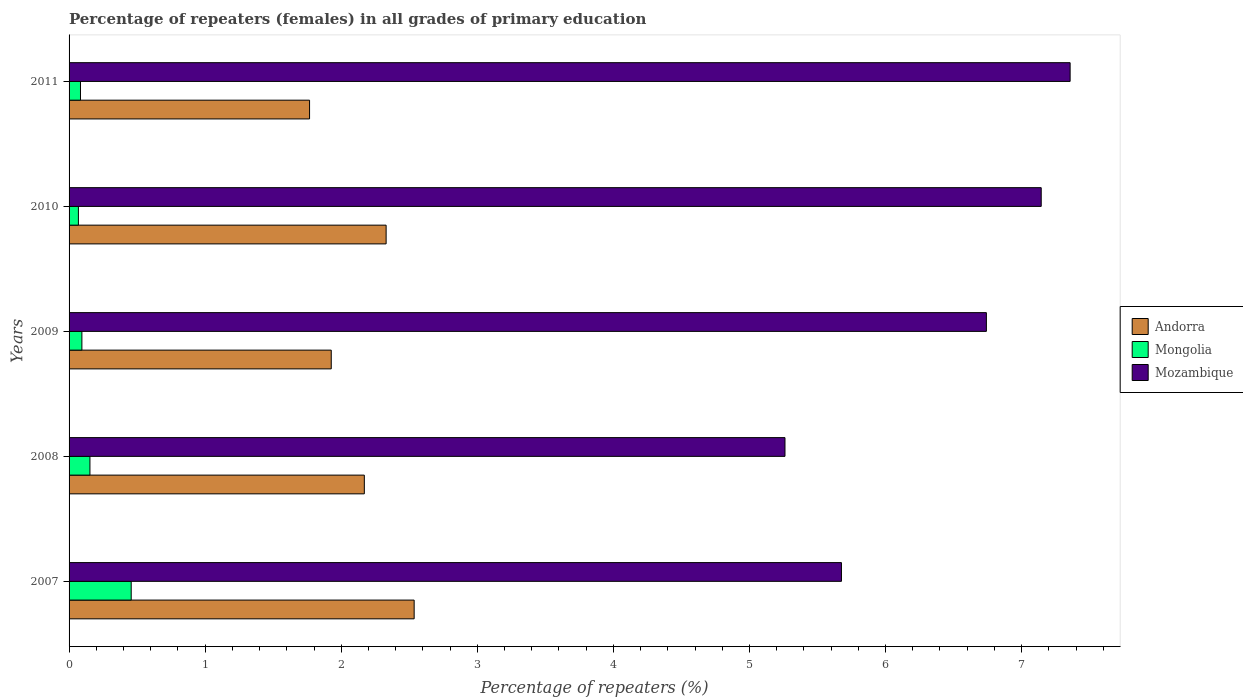How many different coloured bars are there?
Provide a short and direct response. 3. Are the number of bars per tick equal to the number of legend labels?
Your response must be concise. Yes. How many bars are there on the 2nd tick from the top?
Provide a succinct answer. 3. What is the label of the 4th group of bars from the top?
Your response must be concise. 2008. In how many cases, is the number of bars for a given year not equal to the number of legend labels?
Provide a short and direct response. 0. What is the percentage of repeaters (females) in Andorra in 2009?
Give a very brief answer. 1.93. Across all years, what is the maximum percentage of repeaters (females) in Mozambique?
Your response must be concise. 7.36. Across all years, what is the minimum percentage of repeaters (females) in Mongolia?
Offer a terse response. 0.07. What is the total percentage of repeaters (females) in Mozambique in the graph?
Your answer should be compact. 32.18. What is the difference between the percentage of repeaters (females) in Andorra in 2010 and that in 2011?
Provide a short and direct response. 0.56. What is the difference between the percentage of repeaters (females) in Mongolia in 2009 and the percentage of repeaters (females) in Andorra in 2007?
Give a very brief answer. -2.44. What is the average percentage of repeaters (females) in Mozambique per year?
Make the answer very short. 6.44. In the year 2008, what is the difference between the percentage of repeaters (females) in Andorra and percentage of repeaters (females) in Mozambique?
Make the answer very short. -3.09. In how many years, is the percentage of repeaters (females) in Mongolia greater than 4.8 %?
Keep it short and to the point. 0. What is the ratio of the percentage of repeaters (females) in Mongolia in 2007 to that in 2008?
Keep it short and to the point. 2.98. What is the difference between the highest and the second highest percentage of repeaters (females) in Mongolia?
Offer a very short reply. 0.3. What is the difference between the highest and the lowest percentage of repeaters (females) in Andorra?
Offer a very short reply. 0.77. In how many years, is the percentage of repeaters (females) in Mozambique greater than the average percentage of repeaters (females) in Mozambique taken over all years?
Provide a succinct answer. 3. What does the 1st bar from the top in 2009 represents?
Your response must be concise. Mozambique. What does the 1st bar from the bottom in 2010 represents?
Make the answer very short. Andorra. Is it the case that in every year, the sum of the percentage of repeaters (females) in Mozambique and percentage of repeaters (females) in Mongolia is greater than the percentage of repeaters (females) in Andorra?
Provide a succinct answer. Yes. Are all the bars in the graph horizontal?
Your response must be concise. Yes. Are the values on the major ticks of X-axis written in scientific E-notation?
Ensure brevity in your answer.  No. Does the graph contain any zero values?
Offer a terse response. No. How many legend labels are there?
Offer a very short reply. 3. How are the legend labels stacked?
Your response must be concise. Vertical. What is the title of the graph?
Provide a succinct answer. Percentage of repeaters (females) in all grades of primary education. Does "East Asia (all income levels)" appear as one of the legend labels in the graph?
Offer a very short reply. No. What is the label or title of the X-axis?
Give a very brief answer. Percentage of repeaters (%). What is the label or title of the Y-axis?
Give a very brief answer. Years. What is the Percentage of repeaters (%) of Andorra in 2007?
Your answer should be very brief. 2.54. What is the Percentage of repeaters (%) of Mongolia in 2007?
Ensure brevity in your answer.  0.46. What is the Percentage of repeaters (%) in Mozambique in 2007?
Your answer should be very brief. 5.68. What is the Percentage of repeaters (%) of Andorra in 2008?
Make the answer very short. 2.17. What is the Percentage of repeaters (%) in Mongolia in 2008?
Make the answer very short. 0.15. What is the Percentage of repeaters (%) of Mozambique in 2008?
Keep it short and to the point. 5.26. What is the Percentage of repeaters (%) of Andorra in 2009?
Offer a very short reply. 1.93. What is the Percentage of repeaters (%) of Mongolia in 2009?
Offer a very short reply. 0.09. What is the Percentage of repeaters (%) in Mozambique in 2009?
Offer a very short reply. 6.74. What is the Percentage of repeaters (%) in Andorra in 2010?
Your answer should be very brief. 2.33. What is the Percentage of repeaters (%) of Mongolia in 2010?
Provide a short and direct response. 0.07. What is the Percentage of repeaters (%) of Mozambique in 2010?
Keep it short and to the point. 7.14. What is the Percentage of repeaters (%) of Andorra in 2011?
Provide a short and direct response. 1.77. What is the Percentage of repeaters (%) in Mongolia in 2011?
Make the answer very short. 0.08. What is the Percentage of repeaters (%) of Mozambique in 2011?
Offer a terse response. 7.36. Across all years, what is the maximum Percentage of repeaters (%) of Andorra?
Offer a very short reply. 2.54. Across all years, what is the maximum Percentage of repeaters (%) of Mongolia?
Make the answer very short. 0.46. Across all years, what is the maximum Percentage of repeaters (%) in Mozambique?
Offer a very short reply. 7.36. Across all years, what is the minimum Percentage of repeaters (%) in Andorra?
Make the answer very short. 1.77. Across all years, what is the minimum Percentage of repeaters (%) in Mongolia?
Your answer should be very brief. 0.07. Across all years, what is the minimum Percentage of repeaters (%) in Mozambique?
Your answer should be compact. 5.26. What is the total Percentage of repeaters (%) in Andorra in the graph?
Offer a very short reply. 10.73. What is the total Percentage of repeaters (%) in Mongolia in the graph?
Ensure brevity in your answer.  0.86. What is the total Percentage of repeaters (%) of Mozambique in the graph?
Offer a very short reply. 32.18. What is the difference between the Percentage of repeaters (%) of Andorra in 2007 and that in 2008?
Offer a terse response. 0.37. What is the difference between the Percentage of repeaters (%) of Mongolia in 2007 and that in 2008?
Your answer should be compact. 0.3. What is the difference between the Percentage of repeaters (%) in Mozambique in 2007 and that in 2008?
Provide a short and direct response. 0.41. What is the difference between the Percentage of repeaters (%) of Andorra in 2007 and that in 2009?
Your answer should be compact. 0.61. What is the difference between the Percentage of repeaters (%) of Mongolia in 2007 and that in 2009?
Give a very brief answer. 0.36. What is the difference between the Percentage of repeaters (%) of Mozambique in 2007 and that in 2009?
Give a very brief answer. -1.07. What is the difference between the Percentage of repeaters (%) of Andorra in 2007 and that in 2010?
Offer a very short reply. 0.21. What is the difference between the Percentage of repeaters (%) in Mongolia in 2007 and that in 2010?
Your answer should be very brief. 0.39. What is the difference between the Percentage of repeaters (%) in Mozambique in 2007 and that in 2010?
Offer a very short reply. -1.47. What is the difference between the Percentage of repeaters (%) of Andorra in 2007 and that in 2011?
Ensure brevity in your answer.  0.77. What is the difference between the Percentage of repeaters (%) of Mongolia in 2007 and that in 2011?
Ensure brevity in your answer.  0.37. What is the difference between the Percentage of repeaters (%) of Mozambique in 2007 and that in 2011?
Provide a short and direct response. -1.68. What is the difference between the Percentage of repeaters (%) in Andorra in 2008 and that in 2009?
Ensure brevity in your answer.  0.24. What is the difference between the Percentage of repeaters (%) in Mongolia in 2008 and that in 2009?
Offer a very short reply. 0.06. What is the difference between the Percentage of repeaters (%) in Mozambique in 2008 and that in 2009?
Give a very brief answer. -1.48. What is the difference between the Percentage of repeaters (%) in Andorra in 2008 and that in 2010?
Offer a very short reply. -0.16. What is the difference between the Percentage of repeaters (%) in Mongolia in 2008 and that in 2010?
Offer a terse response. 0.08. What is the difference between the Percentage of repeaters (%) in Mozambique in 2008 and that in 2010?
Your answer should be compact. -1.88. What is the difference between the Percentage of repeaters (%) in Andorra in 2008 and that in 2011?
Provide a short and direct response. 0.4. What is the difference between the Percentage of repeaters (%) of Mongolia in 2008 and that in 2011?
Give a very brief answer. 0.07. What is the difference between the Percentage of repeaters (%) of Mozambique in 2008 and that in 2011?
Keep it short and to the point. -2.1. What is the difference between the Percentage of repeaters (%) of Andorra in 2009 and that in 2010?
Your response must be concise. -0.4. What is the difference between the Percentage of repeaters (%) of Mongolia in 2009 and that in 2010?
Offer a very short reply. 0.03. What is the difference between the Percentage of repeaters (%) of Mozambique in 2009 and that in 2010?
Offer a terse response. -0.4. What is the difference between the Percentage of repeaters (%) in Andorra in 2009 and that in 2011?
Make the answer very short. 0.16. What is the difference between the Percentage of repeaters (%) in Mongolia in 2009 and that in 2011?
Your answer should be very brief. 0.01. What is the difference between the Percentage of repeaters (%) of Mozambique in 2009 and that in 2011?
Provide a short and direct response. -0.62. What is the difference between the Percentage of repeaters (%) of Andorra in 2010 and that in 2011?
Your response must be concise. 0.56. What is the difference between the Percentage of repeaters (%) in Mongolia in 2010 and that in 2011?
Your answer should be very brief. -0.02. What is the difference between the Percentage of repeaters (%) in Mozambique in 2010 and that in 2011?
Offer a very short reply. -0.21. What is the difference between the Percentage of repeaters (%) in Andorra in 2007 and the Percentage of repeaters (%) in Mongolia in 2008?
Give a very brief answer. 2.38. What is the difference between the Percentage of repeaters (%) of Andorra in 2007 and the Percentage of repeaters (%) of Mozambique in 2008?
Your answer should be compact. -2.73. What is the difference between the Percentage of repeaters (%) in Mongolia in 2007 and the Percentage of repeaters (%) in Mozambique in 2008?
Your response must be concise. -4.8. What is the difference between the Percentage of repeaters (%) of Andorra in 2007 and the Percentage of repeaters (%) of Mongolia in 2009?
Your response must be concise. 2.44. What is the difference between the Percentage of repeaters (%) of Andorra in 2007 and the Percentage of repeaters (%) of Mozambique in 2009?
Ensure brevity in your answer.  -4.21. What is the difference between the Percentage of repeaters (%) in Mongolia in 2007 and the Percentage of repeaters (%) in Mozambique in 2009?
Offer a very short reply. -6.28. What is the difference between the Percentage of repeaters (%) in Andorra in 2007 and the Percentage of repeaters (%) in Mongolia in 2010?
Make the answer very short. 2.47. What is the difference between the Percentage of repeaters (%) in Andorra in 2007 and the Percentage of repeaters (%) in Mozambique in 2010?
Provide a short and direct response. -4.61. What is the difference between the Percentage of repeaters (%) in Mongolia in 2007 and the Percentage of repeaters (%) in Mozambique in 2010?
Give a very brief answer. -6.69. What is the difference between the Percentage of repeaters (%) of Andorra in 2007 and the Percentage of repeaters (%) of Mongolia in 2011?
Make the answer very short. 2.45. What is the difference between the Percentage of repeaters (%) in Andorra in 2007 and the Percentage of repeaters (%) in Mozambique in 2011?
Provide a succinct answer. -4.82. What is the difference between the Percentage of repeaters (%) in Mongolia in 2007 and the Percentage of repeaters (%) in Mozambique in 2011?
Your response must be concise. -6.9. What is the difference between the Percentage of repeaters (%) of Andorra in 2008 and the Percentage of repeaters (%) of Mongolia in 2009?
Provide a short and direct response. 2.08. What is the difference between the Percentage of repeaters (%) in Andorra in 2008 and the Percentage of repeaters (%) in Mozambique in 2009?
Ensure brevity in your answer.  -4.57. What is the difference between the Percentage of repeaters (%) in Mongolia in 2008 and the Percentage of repeaters (%) in Mozambique in 2009?
Provide a short and direct response. -6.59. What is the difference between the Percentage of repeaters (%) of Andorra in 2008 and the Percentage of repeaters (%) of Mongolia in 2010?
Offer a very short reply. 2.1. What is the difference between the Percentage of repeaters (%) of Andorra in 2008 and the Percentage of repeaters (%) of Mozambique in 2010?
Your answer should be compact. -4.97. What is the difference between the Percentage of repeaters (%) in Mongolia in 2008 and the Percentage of repeaters (%) in Mozambique in 2010?
Make the answer very short. -6.99. What is the difference between the Percentage of repeaters (%) in Andorra in 2008 and the Percentage of repeaters (%) in Mongolia in 2011?
Give a very brief answer. 2.09. What is the difference between the Percentage of repeaters (%) in Andorra in 2008 and the Percentage of repeaters (%) in Mozambique in 2011?
Provide a succinct answer. -5.19. What is the difference between the Percentage of repeaters (%) of Mongolia in 2008 and the Percentage of repeaters (%) of Mozambique in 2011?
Make the answer very short. -7.2. What is the difference between the Percentage of repeaters (%) of Andorra in 2009 and the Percentage of repeaters (%) of Mongolia in 2010?
Provide a succinct answer. 1.86. What is the difference between the Percentage of repeaters (%) in Andorra in 2009 and the Percentage of repeaters (%) in Mozambique in 2010?
Keep it short and to the point. -5.22. What is the difference between the Percentage of repeaters (%) in Mongolia in 2009 and the Percentage of repeaters (%) in Mozambique in 2010?
Offer a very short reply. -7.05. What is the difference between the Percentage of repeaters (%) of Andorra in 2009 and the Percentage of repeaters (%) of Mongolia in 2011?
Keep it short and to the point. 1.84. What is the difference between the Percentage of repeaters (%) in Andorra in 2009 and the Percentage of repeaters (%) in Mozambique in 2011?
Your response must be concise. -5.43. What is the difference between the Percentage of repeaters (%) of Mongolia in 2009 and the Percentage of repeaters (%) of Mozambique in 2011?
Give a very brief answer. -7.26. What is the difference between the Percentage of repeaters (%) in Andorra in 2010 and the Percentage of repeaters (%) in Mongolia in 2011?
Your answer should be very brief. 2.25. What is the difference between the Percentage of repeaters (%) in Andorra in 2010 and the Percentage of repeaters (%) in Mozambique in 2011?
Provide a succinct answer. -5.03. What is the difference between the Percentage of repeaters (%) of Mongolia in 2010 and the Percentage of repeaters (%) of Mozambique in 2011?
Your answer should be very brief. -7.29. What is the average Percentage of repeaters (%) in Andorra per year?
Ensure brevity in your answer.  2.15. What is the average Percentage of repeaters (%) of Mongolia per year?
Your answer should be compact. 0.17. What is the average Percentage of repeaters (%) in Mozambique per year?
Your answer should be compact. 6.44. In the year 2007, what is the difference between the Percentage of repeaters (%) in Andorra and Percentage of repeaters (%) in Mongolia?
Ensure brevity in your answer.  2.08. In the year 2007, what is the difference between the Percentage of repeaters (%) in Andorra and Percentage of repeaters (%) in Mozambique?
Your answer should be compact. -3.14. In the year 2007, what is the difference between the Percentage of repeaters (%) in Mongolia and Percentage of repeaters (%) in Mozambique?
Offer a very short reply. -5.22. In the year 2008, what is the difference between the Percentage of repeaters (%) in Andorra and Percentage of repeaters (%) in Mongolia?
Your answer should be compact. 2.02. In the year 2008, what is the difference between the Percentage of repeaters (%) of Andorra and Percentage of repeaters (%) of Mozambique?
Your response must be concise. -3.09. In the year 2008, what is the difference between the Percentage of repeaters (%) of Mongolia and Percentage of repeaters (%) of Mozambique?
Provide a short and direct response. -5.11. In the year 2009, what is the difference between the Percentage of repeaters (%) in Andorra and Percentage of repeaters (%) in Mongolia?
Give a very brief answer. 1.83. In the year 2009, what is the difference between the Percentage of repeaters (%) of Andorra and Percentage of repeaters (%) of Mozambique?
Offer a very short reply. -4.81. In the year 2009, what is the difference between the Percentage of repeaters (%) in Mongolia and Percentage of repeaters (%) in Mozambique?
Keep it short and to the point. -6.65. In the year 2010, what is the difference between the Percentage of repeaters (%) of Andorra and Percentage of repeaters (%) of Mongolia?
Offer a very short reply. 2.26. In the year 2010, what is the difference between the Percentage of repeaters (%) in Andorra and Percentage of repeaters (%) in Mozambique?
Provide a succinct answer. -4.81. In the year 2010, what is the difference between the Percentage of repeaters (%) in Mongolia and Percentage of repeaters (%) in Mozambique?
Your response must be concise. -7.08. In the year 2011, what is the difference between the Percentage of repeaters (%) of Andorra and Percentage of repeaters (%) of Mongolia?
Make the answer very short. 1.68. In the year 2011, what is the difference between the Percentage of repeaters (%) in Andorra and Percentage of repeaters (%) in Mozambique?
Your answer should be very brief. -5.59. In the year 2011, what is the difference between the Percentage of repeaters (%) of Mongolia and Percentage of repeaters (%) of Mozambique?
Your response must be concise. -7.27. What is the ratio of the Percentage of repeaters (%) of Andorra in 2007 to that in 2008?
Provide a short and direct response. 1.17. What is the ratio of the Percentage of repeaters (%) in Mongolia in 2007 to that in 2008?
Give a very brief answer. 2.98. What is the ratio of the Percentage of repeaters (%) of Mozambique in 2007 to that in 2008?
Keep it short and to the point. 1.08. What is the ratio of the Percentage of repeaters (%) in Andorra in 2007 to that in 2009?
Ensure brevity in your answer.  1.32. What is the ratio of the Percentage of repeaters (%) of Mongolia in 2007 to that in 2009?
Offer a terse response. 4.85. What is the ratio of the Percentage of repeaters (%) in Mozambique in 2007 to that in 2009?
Make the answer very short. 0.84. What is the ratio of the Percentage of repeaters (%) of Andorra in 2007 to that in 2010?
Offer a very short reply. 1.09. What is the ratio of the Percentage of repeaters (%) in Mongolia in 2007 to that in 2010?
Your response must be concise. 6.66. What is the ratio of the Percentage of repeaters (%) of Mozambique in 2007 to that in 2010?
Ensure brevity in your answer.  0.79. What is the ratio of the Percentage of repeaters (%) of Andorra in 2007 to that in 2011?
Offer a terse response. 1.43. What is the ratio of the Percentage of repeaters (%) of Mongolia in 2007 to that in 2011?
Offer a terse response. 5.44. What is the ratio of the Percentage of repeaters (%) in Mozambique in 2007 to that in 2011?
Offer a very short reply. 0.77. What is the ratio of the Percentage of repeaters (%) of Andorra in 2008 to that in 2009?
Give a very brief answer. 1.13. What is the ratio of the Percentage of repeaters (%) in Mongolia in 2008 to that in 2009?
Your answer should be compact. 1.63. What is the ratio of the Percentage of repeaters (%) in Mozambique in 2008 to that in 2009?
Provide a short and direct response. 0.78. What is the ratio of the Percentage of repeaters (%) in Andorra in 2008 to that in 2010?
Provide a succinct answer. 0.93. What is the ratio of the Percentage of repeaters (%) of Mongolia in 2008 to that in 2010?
Provide a succinct answer. 2.24. What is the ratio of the Percentage of repeaters (%) in Mozambique in 2008 to that in 2010?
Offer a terse response. 0.74. What is the ratio of the Percentage of repeaters (%) in Andorra in 2008 to that in 2011?
Keep it short and to the point. 1.23. What is the ratio of the Percentage of repeaters (%) in Mongolia in 2008 to that in 2011?
Keep it short and to the point. 1.83. What is the ratio of the Percentage of repeaters (%) in Mozambique in 2008 to that in 2011?
Make the answer very short. 0.72. What is the ratio of the Percentage of repeaters (%) in Andorra in 2009 to that in 2010?
Offer a terse response. 0.83. What is the ratio of the Percentage of repeaters (%) in Mongolia in 2009 to that in 2010?
Your answer should be very brief. 1.37. What is the ratio of the Percentage of repeaters (%) of Mozambique in 2009 to that in 2010?
Provide a succinct answer. 0.94. What is the ratio of the Percentage of repeaters (%) of Andorra in 2009 to that in 2011?
Your answer should be very brief. 1.09. What is the ratio of the Percentage of repeaters (%) of Mongolia in 2009 to that in 2011?
Provide a succinct answer. 1.12. What is the ratio of the Percentage of repeaters (%) of Mozambique in 2009 to that in 2011?
Your answer should be very brief. 0.92. What is the ratio of the Percentage of repeaters (%) in Andorra in 2010 to that in 2011?
Provide a succinct answer. 1.32. What is the ratio of the Percentage of repeaters (%) of Mongolia in 2010 to that in 2011?
Your response must be concise. 0.82. What is the ratio of the Percentage of repeaters (%) of Mozambique in 2010 to that in 2011?
Ensure brevity in your answer.  0.97. What is the difference between the highest and the second highest Percentage of repeaters (%) of Andorra?
Keep it short and to the point. 0.21. What is the difference between the highest and the second highest Percentage of repeaters (%) in Mongolia?
Give a very brief answer. 0.3. What is the difference between the highest and the second highest Percentage of repeaters (%) of Mozambique?
Provide a short and direct response. 0.21. What is the difference between the highest and the lowest Percentage of repeaters (%) of Andorra?
Your response must be concise. 0.77. What is the difference between the highest and the lowest Percentage of repeaters (%) of Mongolia?
Your answer should be compact. 0.39. What is the difference between the highest and the lowest Percentage of repeaters (%) in Mozambique?
Your answer should be compact. 2.1. 